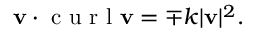Convert formula to latex. <formula><loc_0><loc_0><loc_500><loc_500>v \cdot c u r l v = \mp k | v | ^ { 2 } .</formula> 